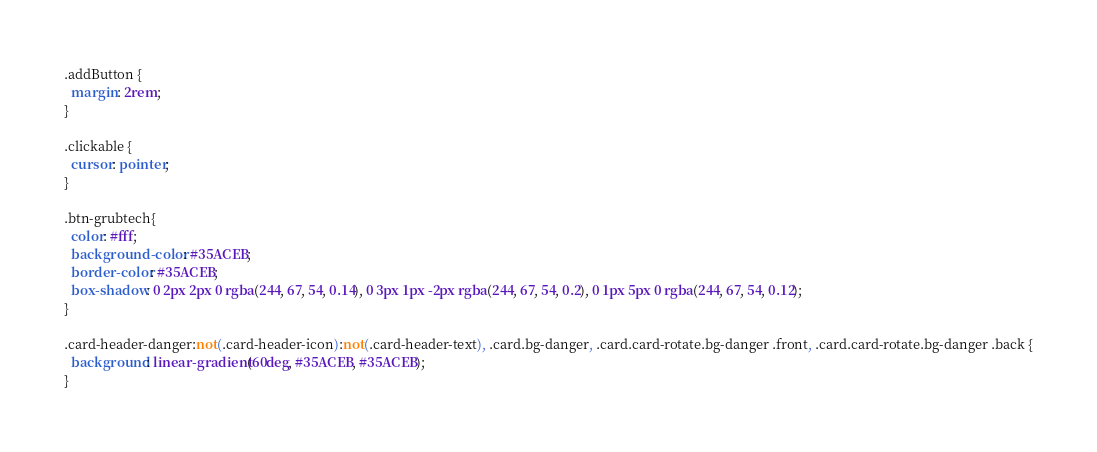<code> <loc_0><loc_0><loc_500><loc_500><_CSS_>.addButton {
  margin: 2rem;
}

.clickable {
  cursor: pointer;
}

.btn-grubtech{
  color: #fff;
  background-color: #35ACEB;
  border-color: #35ACEB;
  box-shadow: 0 2px 2px 0 rgba(244, 67, 54, 0.14), 0 3px 1px -2px rgba(244, 67, 54, 0.2), 0 1px 5px 0 rgba(244, 67, 54, 0.12);    
}

.card-header-danger:not(.card-header-icon):not(.card-header-text), .card.bg-danger, .card.card-rotate.bg-danger .front, .card.card-rotate.bg-danger .back {
  background: linear-gradient(60deg, #35ACEB, #35ACEB);
}

</code> 